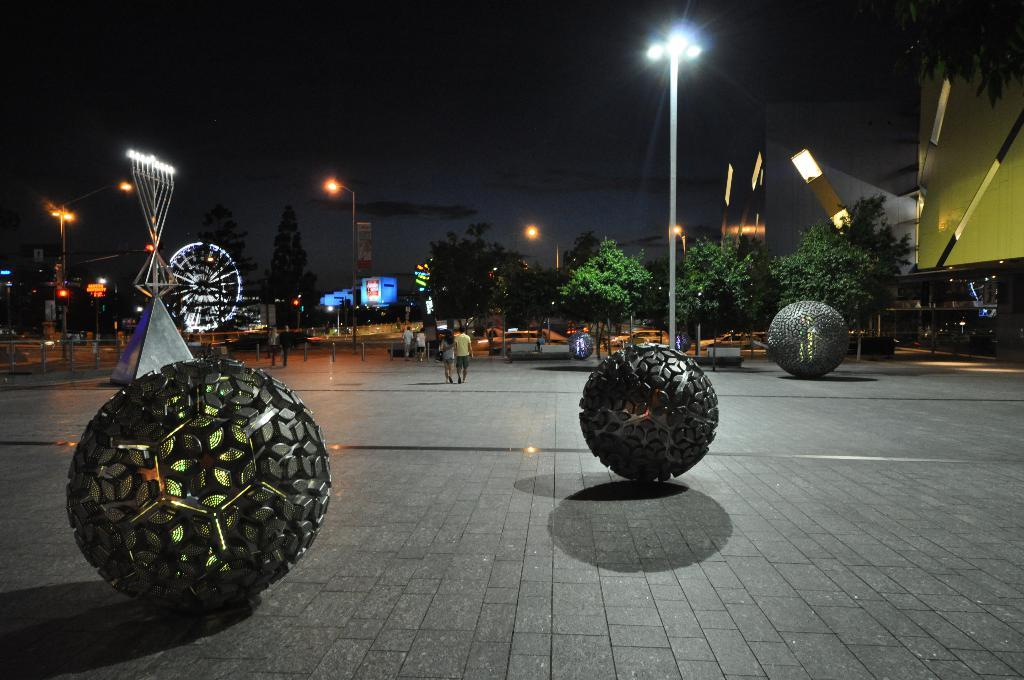What objects are on the road in the image? There are balls on the road in the image. What are the people in the image doing? The people in the image are walking on the road. What can be seen in the background of the image? There are buildings visible in the image. What type of religious ceremony is taking place in the image? There is no indication of a religious ceremony in the image; it features balls on the road and people walking. Can you tell me how many sticks are being used by the people in the image? There are no sticks present in the image; the people are walking without any visible sticks. 